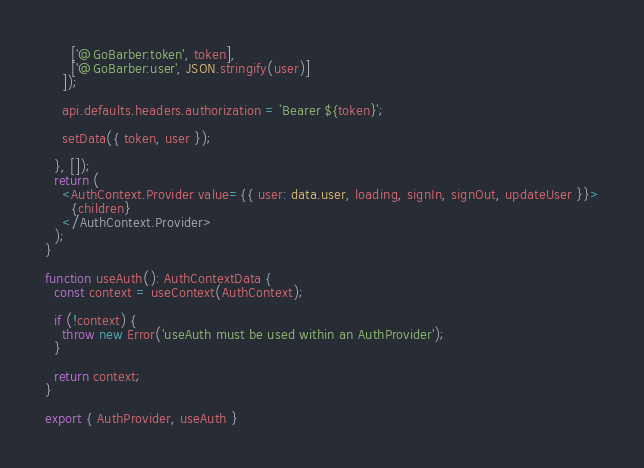<code> <loc_0><loc_0><loc_500><loc_500><_TypeScript_>      ['@GoBarber:token', token],
      ['@GoBarber:user', JSON.stringify(user)]
    ]);

    api.defaults.headers.authorization = `Bearer ${token}`;

    setData({ token, user });

  }, []);
  return (
    <AuthContext.Provider value={{ user: data.user, loading, signIn, signOut, updateUser }}>
      {children}
    </AuthContext.Provider>
  );
}

function useAuth(): AuthContextData {
  const context = useContext(AuthContext);

  if (!context) {
    throw new Error('useAuth must be used within an AuthProvider');
  }

  return context;
}

export { AuthProvider, useAuth }

</code> 